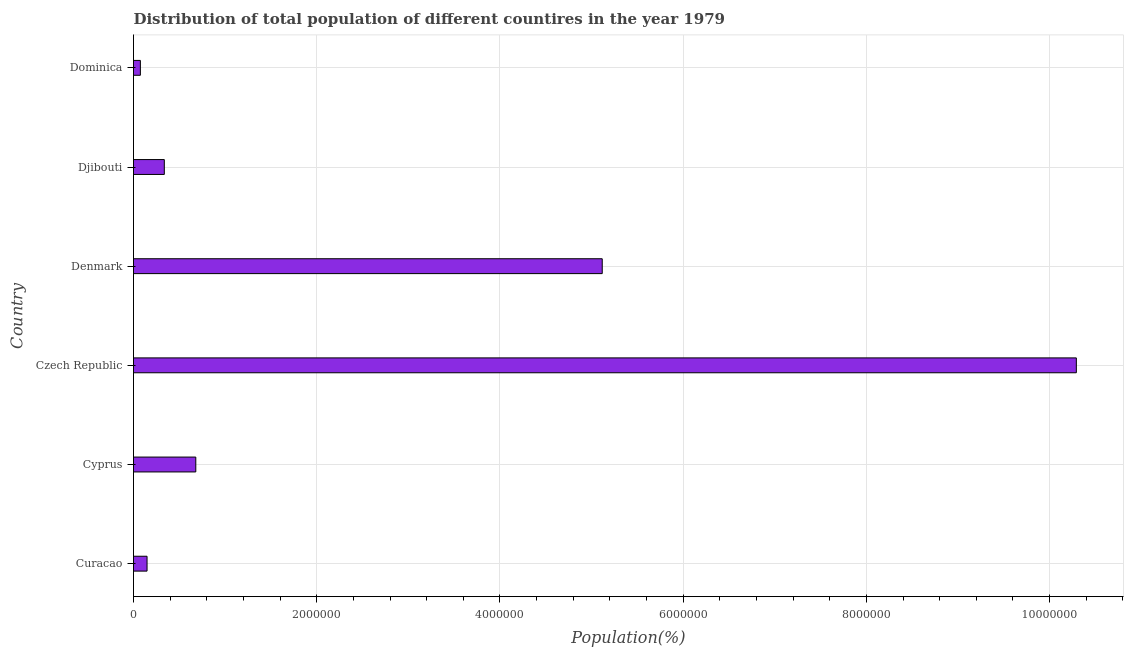Does the graph contain grids?
Offer a very short reply. Yes. What is the title of the graph?
Your response must be concise. Distribution of total population of different countires in the year 1979. What is the label or title of the X-axis?
Offer a very short reply. Population(%). What is the label or title of the Y-axis?
Offer a terse response. Country. What is the population in Czech Republic?
Ensure brevity in your answer.  1.03e+07. Across all countries, what is the maximum population?
Provide a short and direct response. 1.03e+07. Across all countries, what is the minimum population?
Offer a terse response. 7.49e+04. In which country was the population maximum?
Provide a short and direct response. Czech Republic. In which country was the population minimum?
Make the answer very short. Dominica. What is the sum of the population?
Offer a very short reply. 1.66e+07. What is the difference between the population in Denmark and Djibouti?
Make the answer very short. 4.78e+06. What is the average population per country?
Keep it short and to the point. 2.77e+06. What is the median population?
Your response must be concise. 5.08e+05. In how many countries, is the population greater than 10000000 %?
Offer a very short reply. 1. What is the ratio of the population in Cyprus to that in Dominica?
Ensure brevity in your answer.  9.08. What is the difference between the highest and the second highest population?
Provide a succinct answer. 5.18e+06. Is the sum of the population in Djibouti and Dominica greater than the maximum population across all countries?
Provide a succinct answer. No. What is the difference between the highest and the lowest population?
Give a very brief answer. 1.02e+07. How many bars are there?
Ensure brevity in your answer.  6. What is the Population(%) in Curacao?
Keep it short and to the point. 1.48e+05. What is the Population(%) of Cyprus?
Make the answer very short. 6.80e+05. What is the Population(%) of Czech Republic?
Make the answer very short. 1.03e+07. What is the Population(%) of Denmark?
Provide a succinct answer. 5.12e+06. What is the Population(%) of Djibouti?
Offer a very short reply. 3.36e+05. What is the Population(%) of Dominica?
Your answer should be very brief. 7.49e+04. What is the difference between the Population(%) in Curacao and Cyprus?
Offer a terse response. -5.32e+05. What is the difference between the Population(%) in Curacao and Czech Republic?
Provide a succinct answer. -1.01e+07. What is the difference between the Population(%) in Curacao and Denmark?
Your response must be concise. -4.97e+06. What is the difference between the Population(%) in Curacao and Djibouti?
Ensure brevity in your answer.  -1.88e+05. What is the difference between the Population(%) in Curacao and Dominica?
Keep it short and to the point. 7.29e+04. What is the difference between the Population(%) in Cyprus and Czech Republic?
Provide a short and direct response. -9.61e+06. What is the difference between the Population(%) in Cyprus and Denmark?
Your response must be concise. -4.44e+06. What is the difference between the Population(%) in Cyprus and Djibouti?
Your response must be concise. 3.44e+05. What is the difference between the Population(%) in Cyprus and Dominica?
Provide a short and direct response. 6.05e+05. What is the difference between the Population(%) in Czech Republic and Denmark?
Ensure brevity in your answer.  5.18e+06. What is the difference between the Population(%) in Czech Republic and Djibouti?
Give a very brief answer. 9.96e+06. What is the difference between the Population(%) in Czech Republic and Dominica?
Ensure brevity in your answer.  1.02e+07. What is the difference between the Population(%) in Denmark and Djibouti?
Provide a short and direct response. 4.78e+06. What is the difference between the Population(%) in Denmark and Dominica?
Keep it short and to the point. 5.04e+06. What is the difference between the Population(%) in Djibouti and Dominica?
Provide a short and direct response. 2.61e+05. What is the ratio of the Population(%) in Curacao to that in Cyprus?
Your response must be concise. 0.22. What is the ratio of the Population(%) in Curacao to that in Czech Republic?
Your answer should be compact. 0.01. What is the ratio of the Population(%) in Curacao to that in Denmark?
Provide a succinct answer. 0.03. What is the ratio of the Population(%) in Curacao to that in Djibouti?
Provide a succinct answer. 0.44. What is the ratio of the Population(%) in Curacao to that in Dominica?
Ensure brevity in your answer.  1.97. What is the ratio of the Population(%) in Cyprus to that in Czech Republic?
Offer a terse response. 0.07. What is the ratio of the Population(%) in Cyprus to that in Denmark?
Ensure brevity in your answer.  0.13. What is the ratio of the Population(%) in Cyprus to that in Djibouti?
Make the answer very short. 2.02. What is the ratio of the Population(%) in Cyprus to that in Dominica?
Your response must be concise. 9.08. What is the ratio of the Population(%) in Czech Republic to that in Denmark?
Your answer should be very brief. 2.01. What is the ratio of the Population(%) in Czech Republic to that in Djibouti?
Ensure brevity in your answer.  30.61. What is the ratio of the Population(%) in Czech Republic to that in Dominica?
Offer a terse response. 137.37. What is the ratio of the Population(%) in Denmark to that in Djibouti?
Your answer should be compact. 15.22. What is the ratio of the Population(%) in Denmark to that in Dominica?
Your response must be concise. 68.29. What is the ratio of the Population(%) in Djibouti to that in Dominica?
Keep it short and to the point. 4.49. 